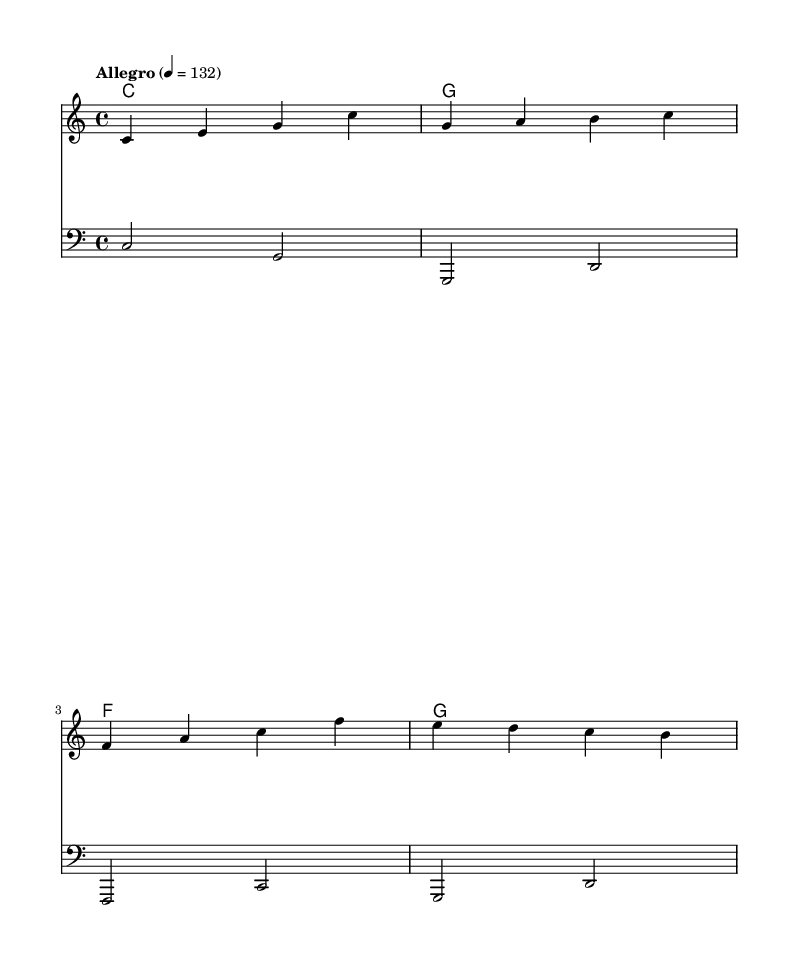What is the key signature of this music? The key signature indicated is "C major," which has no sharps or flats. It is shown at the beginning of the staff before the notes start.
Answer: C major What is the time signature of this music? The time signature is "4/4," which means there are four beats in each measure, and it is also located at the beginning of the staff, indicating how the music is rhythmically organized.
Answer: 4/4 What is the tempo marking for this piece? The tempo marking is "Allegro," which means it is to be played quickly. The specific BPM (beats per minute) indicated is 132, shown in the tempo text at the start of the music.
Answer: Allegro How many measures are there in the melody? The melody consists of four measures; you can count them by looking at the vertical lines that separate groups of notes, which indicate the end of each measure.
Answer: 4 What instruments are indicated in the score? The score shows three instruments: the main melody played on "acoustic grand," chords on "ChordNames," and a bass line labeled "acoustic bass." This is indicated by the instruments set right before each staff.
Answer: Acoustic grand, acoustic bass Which chord appears in the first measure? The first measure contains the chord "C," which is indicated in the chord symbols above the melody notes, showing the harmony for that section.
Answer: C How many different chords are used in this piece? There are three different chords used in total: "C," "G," and "F," shown in the chord symbols throughout the score. You can derive this by checking each measure's chord changes.
Answer: 3 